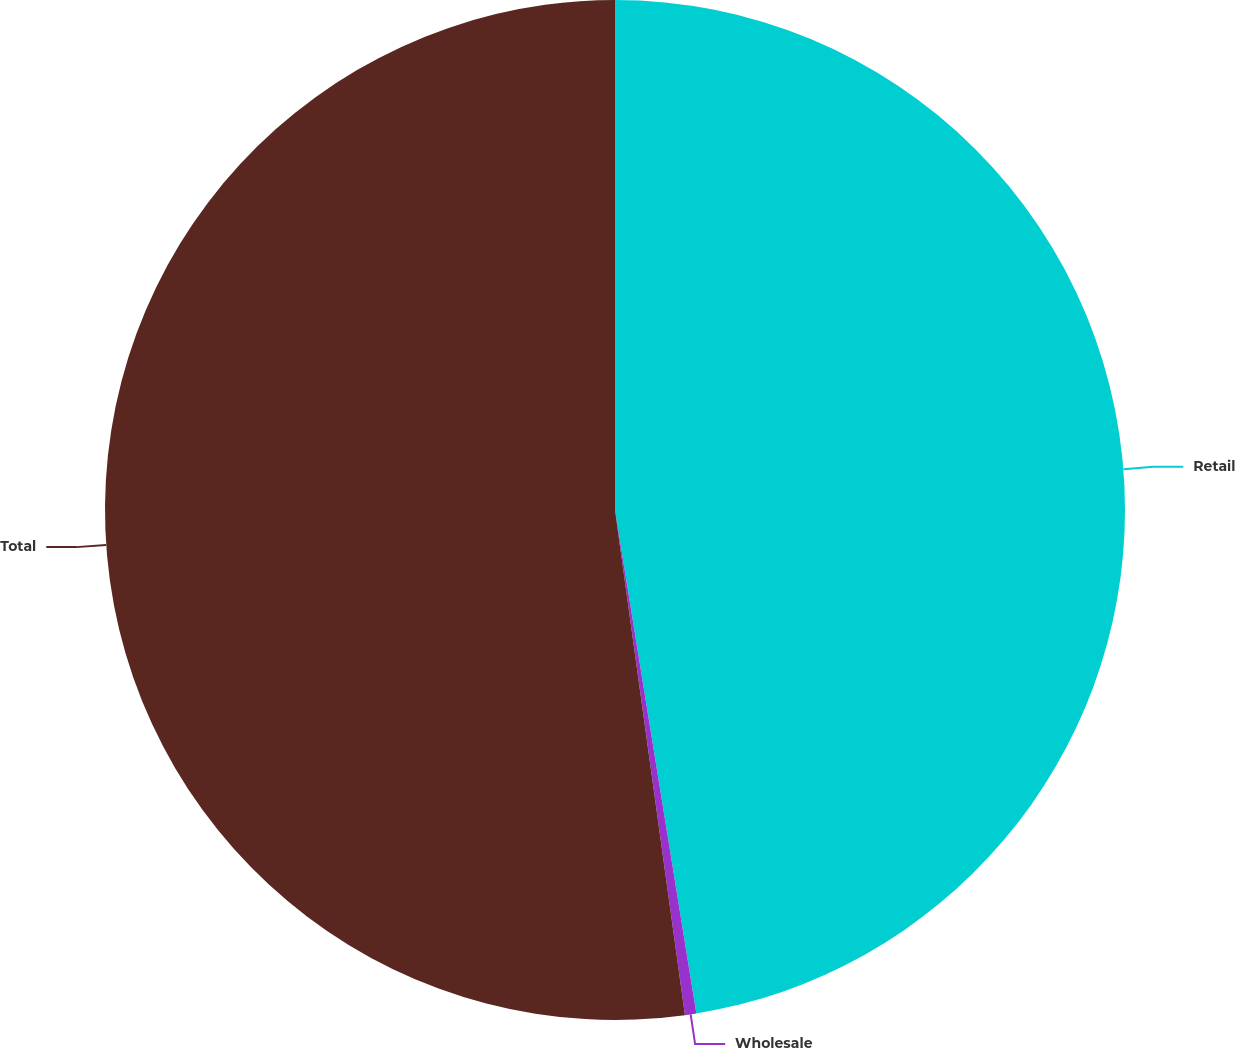Convert chart. <chart><loc_0><loc_0><loc_500><loc_500><pie_chart><fcel>Retail<fcel>Wholesale<fcel>Total<nl><fcel>47.45%<fcel>0.36%<fcel>52.19%<nl></chart> 